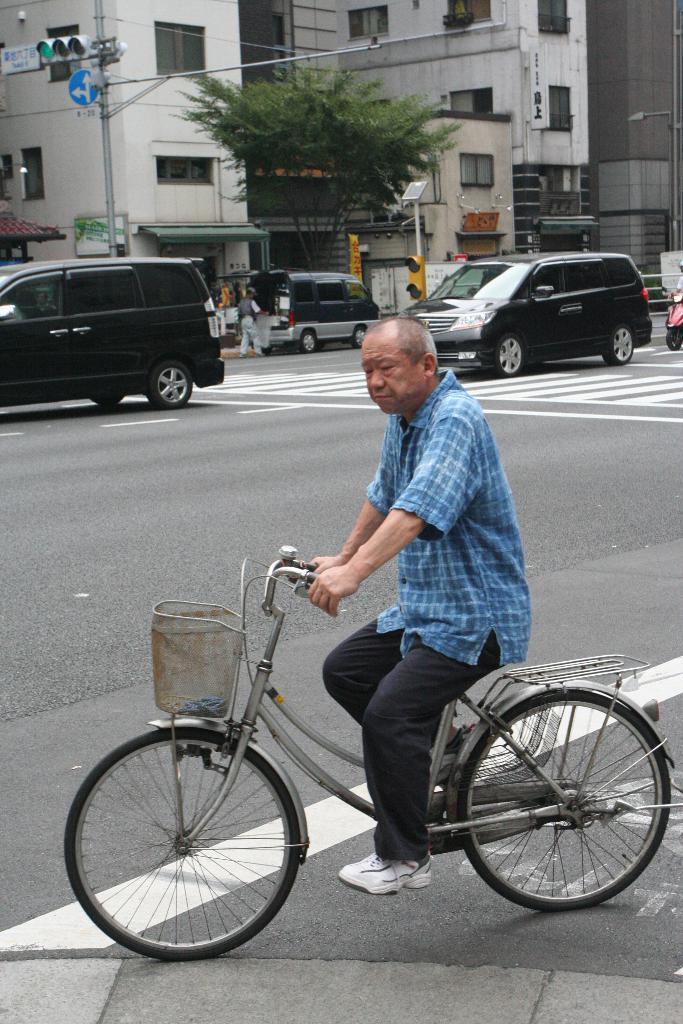Could you give a brief overview of what you see in this image? In this image In the middle there is a man he is riding bicycle he wear shirt,trouser and shoes. In the back ground there are some vehicles, people, tree, traffic signal and building. 